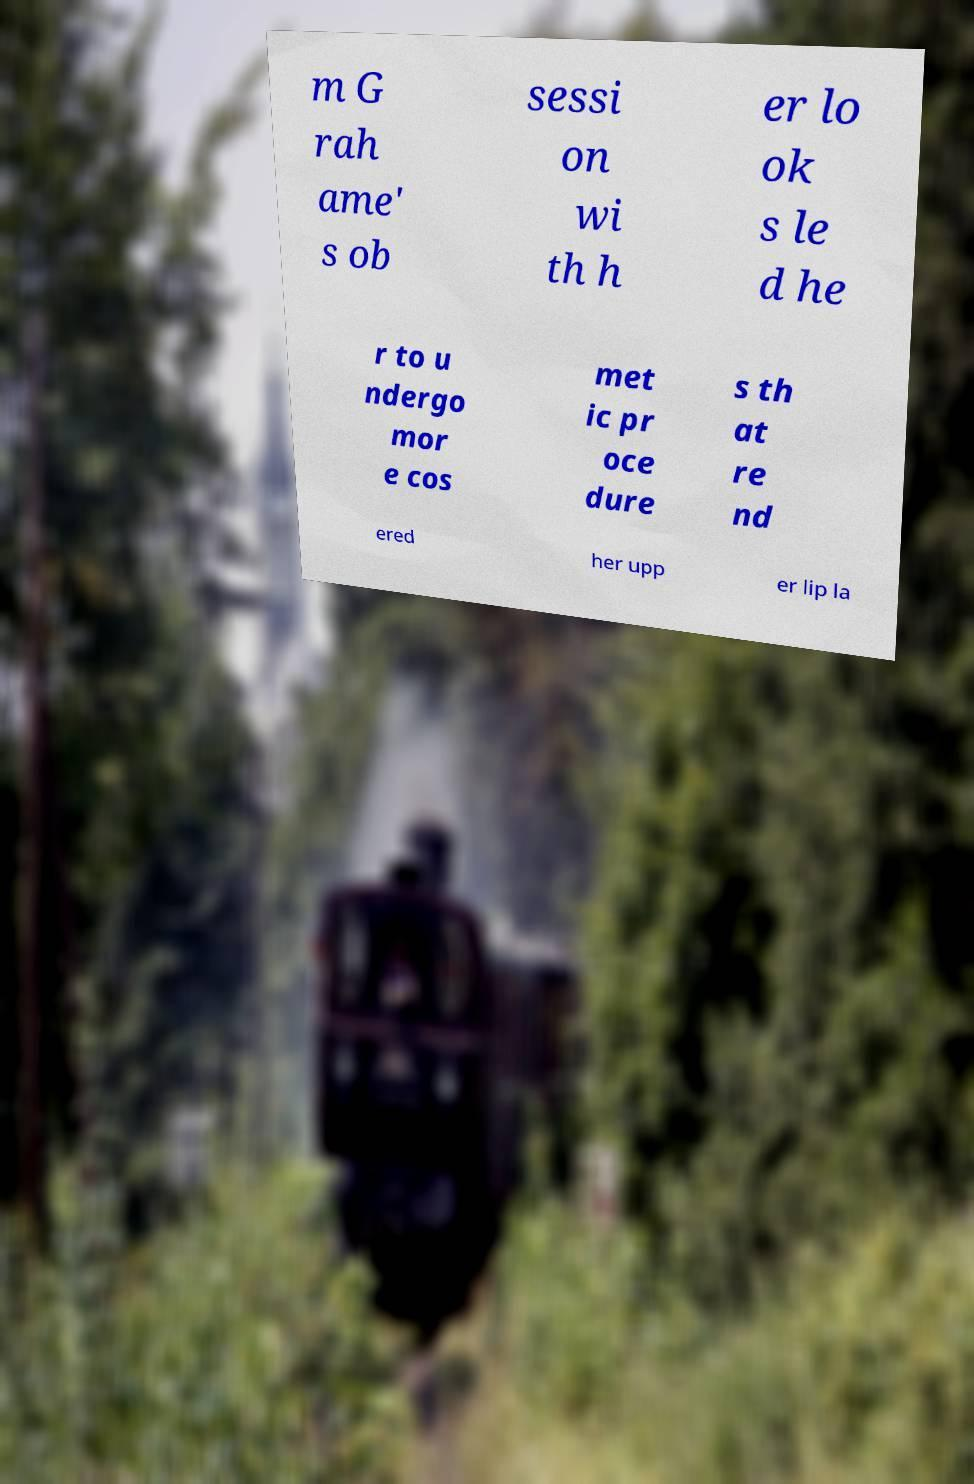Could you extract and type out the text from this image? m G rah ame' s ob sessi on wi th h er lo ok s le d he r to u ndergo mor e cos met ic pr oce dure s th at re nd ered her upp er lip la 